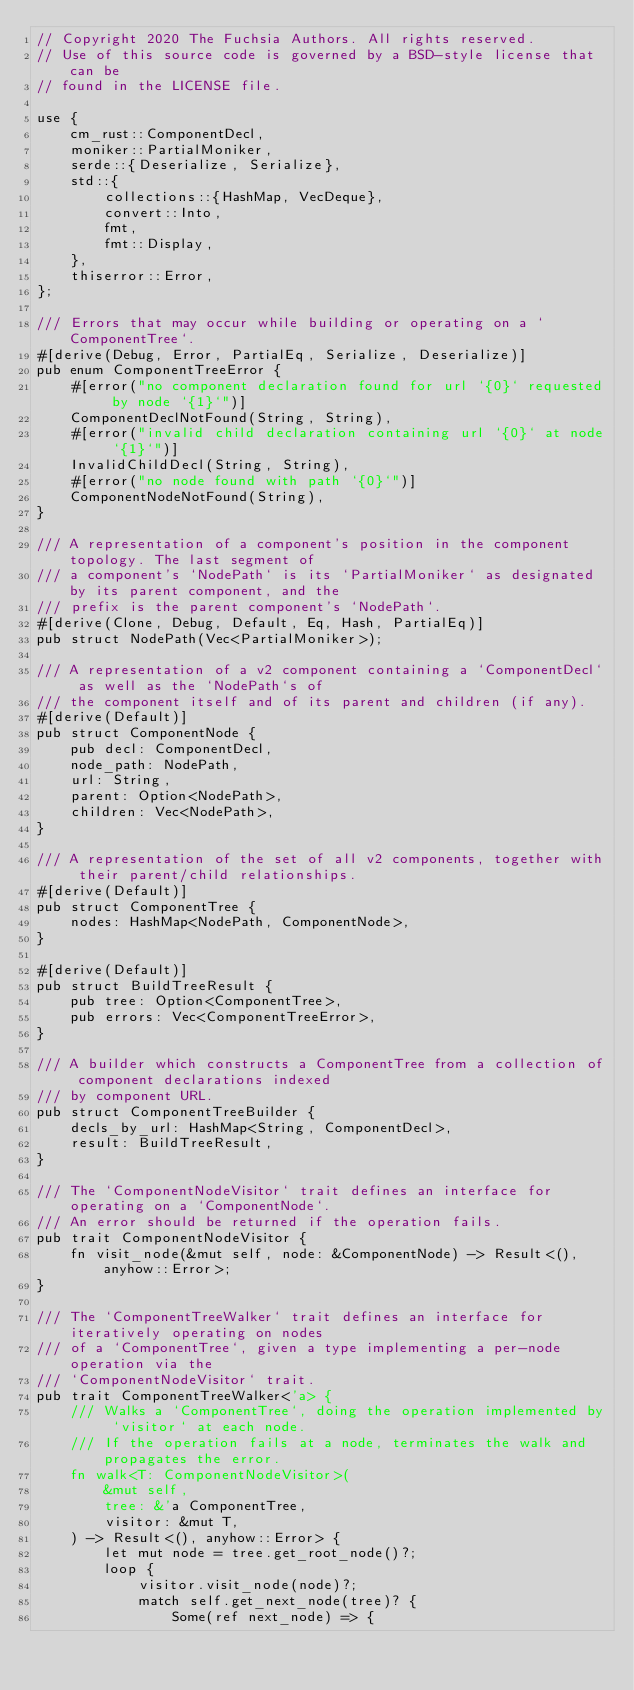<code> <loc_0><loc_0><loc_500><loc_500><_Rust_>// Copyright 2020 The Fuchsia Authors. All rights reserved.
// Use of this source code is governed by a BSD-style license that can be
// found in the LICENSE file.

use {
    cm_rust::ComponentDecl,
    moniker::PartialMoniker,
    serde::{Deserialize, Serialize},
    std::{
        collections::{HashMap, VecDeque},
        convert::Into,
        fmt,
        fmt::Display,
    },
    thiserror::Error,
};

/// Errors that may occur while building or operating on a `ComponentTree`.
#[derive(Debug, Error, PartialEq, Serialize, Deserialize)]
pub enum ComponentTreeError {
    #[error("no component declaration found for url `{0}` requested by node `{1}`")]
    ComponentDeclNotFound(String, String),
    #[error("invalid child declaration containing url `{0}` at node `{1}`")]
    InvalidChildDecl(String, String),
    #[error("no node found with path `{0}`")]
    ComponentNodeNotFound(String),
}

/// A representation of a component's position in the component topology. The last segment of
/// a component's `NodePath` is its `PartialMoniker` as designated by its parent component, and the
/// prefix is the parent component's `NodePath`.
#[derive(Clone, Debug, Default, Eq, Hash, PartialEq)]
pub struct NodePath(Vec<PartialMoniker>);

/// A representation of a v2 component containing a `ComponentDecl` as well as the `NodePath`s of
/// the component itself and of its parent and children (if any).
#[derive(Default)]
pub struct ComponentNode {
    pub decl: ComponentDecl,
    node_path: NodePath,
    url: String,
    parent: Option<NodePath>,
    children: Vec<NodePath>,
}

/// A representation of the set of all v2 components, together with their parent/child relationships.
#[derive(Default)]
pub struct ComponentTree {
    nodes: HashMap<NodePath, ComponentNode>,
}

#[derive(Default)]
pub struct BuildTreeResult {
    pub tree: Option<ComponentTree>,
    pub errors: Vec<ComponentTreeError>,
}

/// A builder which constructs a ComponentTree from a collection of component declarations indexed
/// by component URL.
pub struct ComponentTreeBuilder {
    decls_by_url: HashMap<String, ComponentDecl>,
    result: BuildTreeResult,
}

/// The `ComponentNodeVisitor` trait defines an interface for operating on a `ComponentNode`.
/// An error should be returned if the operation fails.
pub trait ComponentNodeVisitor {
    fn visit_node(&mut self, node: &ComponentNode) -> Result<(), anyhow::Error>;
}

/// The `ComponentTreeWalker` trait defines an interface for iteratively operating on nodes
/// of a `ComponentTree`, given a type implementing a per-node operation via the
/// `ComponentNodeVisitor` trait.
pub trait ComponentTreeWalker<'a> {
    /// Walks a `ComponentTree`, doing the operation implemented by `visitor` at each node.
    /// If the operation fails at a node, terminates the walk and propagates the error.
    fn walk<T: ComponentNodeVisitor>(
        &mut self,
        tree: &'a ComponentTree,
        visitor: &mut T,
    ) -> Result<(), anyhow::Error> {
        let mut node = tree.get_root_node()?;
        loop {
            visitor.visit_node(node)?;
            match self.get_next_node(tree)? {
                Some(ref next_node) => {</code> 